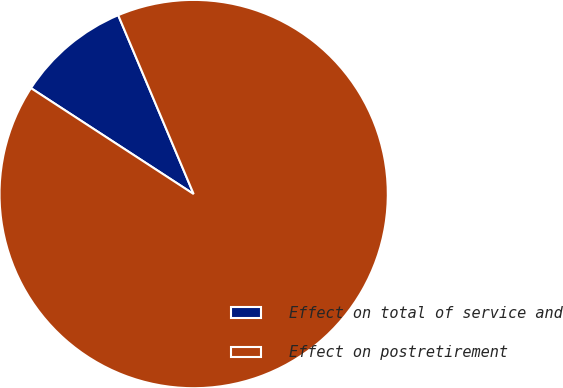Convert chart to OTSL. <chart><loc_0><loc_0><loc_500><loc_500><pie_chart><fcel>Effect on total of service and<fcel>Effect on postretirement<nl><fcel>9.46%<fcel>90.54%<nl></chart> 